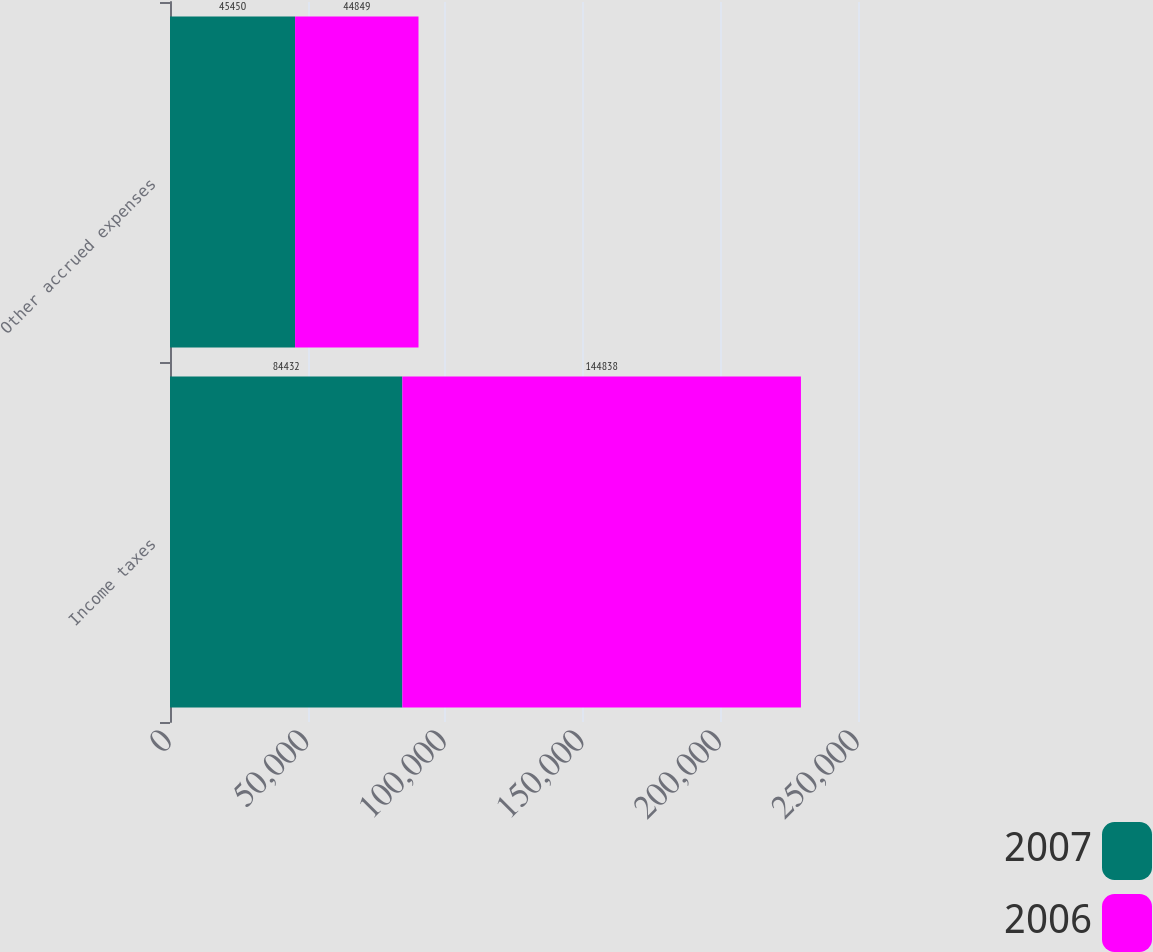Convert chart. <chart><loc_0><loc_0><loc_500><loc_500><stacked_bar_chart><ecel><fcel>Income taxes<fcel>Other accrued expenses<nl><fcel>2007<fcel>84432<fcel>45450<nl><fcel>2006<fcel>144838<fcel>44849<nl></chart> 